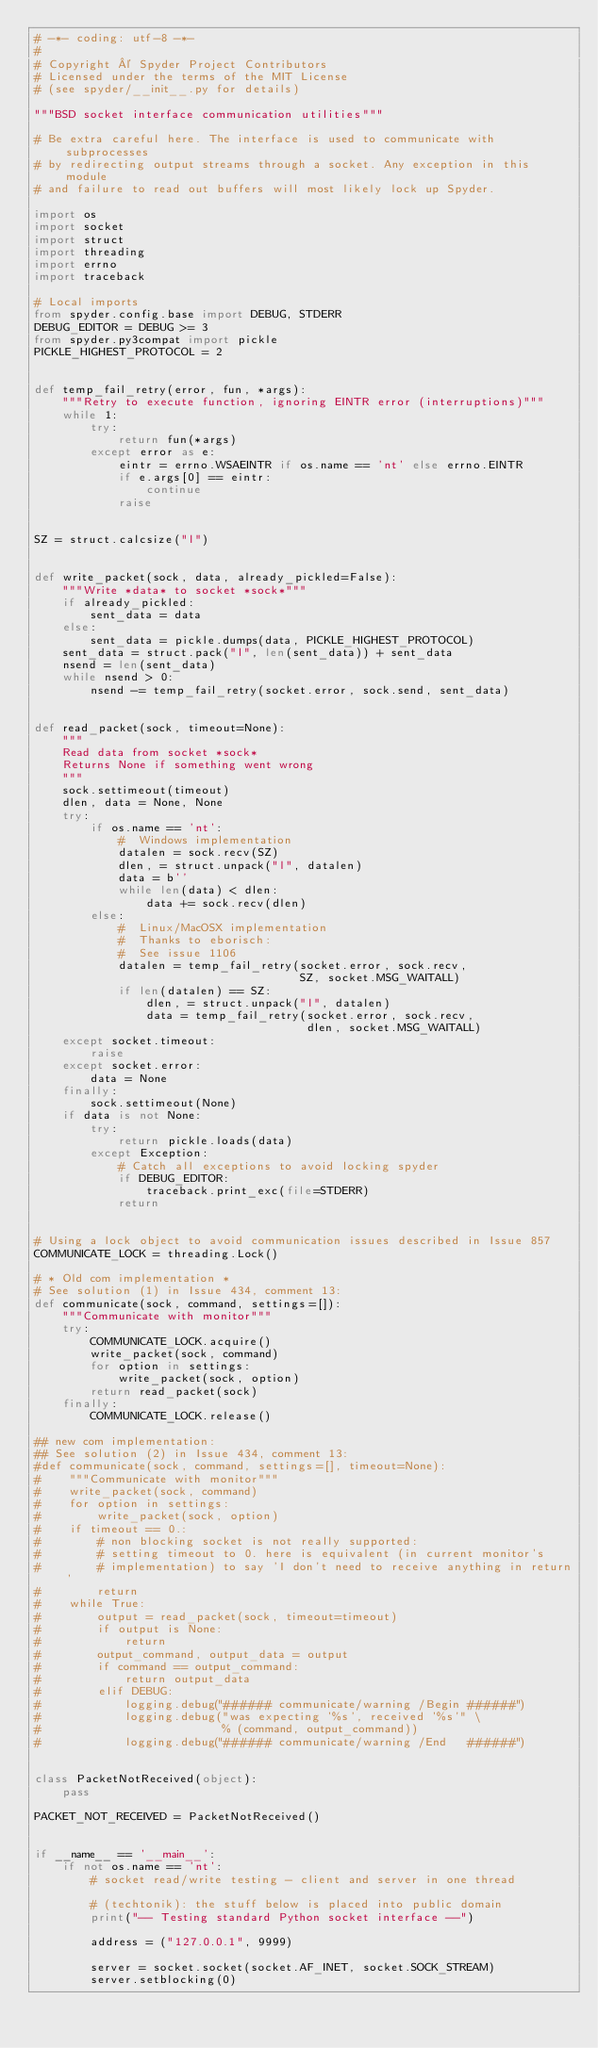<code> <loc_0><loc_0><loc_500><loc_500><_Python_># -*- coding: utf-8 -*-
#
# Copyright © Spyder Project Contributors
# Licensed under the terms of the MIT License
# (see spyder/__init__.py for details)

"""BSD socket interface communication utilities"""

# Be extra careful here. The interface is used to communicate with subprocesses
# by redirecting output streams through a socket. Any exception in this module
# and failure to read out buffers will most likely lock up Spyder.

import os
import socket
import struct
import threading
import errno
import traceback

# Local imports
from spyder.config.base import DEBUG, STDERR
DEBUG_EDITOR = DEBUG >= 3
from spyder.py3compat import pickle
PICKLE_HIGHEST_PROTOCOL = 2


def temp_fail_retry(error, fun, *args):
    """Retry to execute function, ignoring EINTR error (interruptions)"""
    while 1:
        try:
            return fun(*args)
        except error as e:
            eintr = errno.WSAEINTR if os.name == 'nt' else errno.EINTR
            if e.args[0] == eintr:
                continue
            raise


SZ = struct.calcsize("l")


def write_packet(sock, data, already_pickled=False):
    """Write *data* to socket *sock*"""
    if already_pickled:
        sent_data = data
    else:
        sent_data = pickle.dumps(data, PICKLE_HIGHEST_PROTOCOL)
    sent_data = struct.pack("l", len(sent_data)) + sent_data
    nsend = len(sent_data)
    while nsend > 0:
        nsend -= temp_fail_retry(socket.error, sock.send, sent_data)


def read_packet(sock, timeout=None):
    """
    Read data from socket *sock*
    Returns None if something went wrong
    """
    sock.settimeout(timeout)
    dlen, data = None, None
    try:
        if os.name == 'nt':
            #  Windows implementation
            datalen = sock.recv(SZ)
            dlen, = struct.unpack("l", datalen)
            data = b''
            while len(data) < dlen:
                data += sock.recv(dlen)
        else:
            #  Linux/MacOSX implementation
            #  Thanks to eborisch:
            #  See issue 1106
            datalen = temp_fail_retry(socket.error, sock.recv,
                                      SZ, socket.MSG_WAITALL)
            if len(datalen) == SZ:
                dlen, = struct.unpack("l", datalen)
                data = temp_fail_retry(socket.error, sock.recv,
                                       dlen, socket.MSG_WAITALL)
    except socket.timeout:
        raise
    except socket.error:
        data = None
    finally:
        sock.settimeout(None)
    if data is not None:
        try:
            return pickle.loads(data)
        except Exception:
            # Catch all exceptions to avoid locking spyder
            if DEBUG_EDITOR:
                traceback.print_exc(file=STDERR)
            return


# Using a lock object to avoid communication issues described in Issue 857
COMMUNICATE_LOCK = threading.Lock()

# * Old com implementation *
# See solution (1) in Issue 434, comment 13:
def communicate(sock, command, settings=[]):
    """Communicate with monitor"""
    try:
        COMMUNICATE_LOCK.acquire()
        write_packet(sock, command)
        for option in settings:
            write_packet(sock, option)
        return read_packet(sock)
    finally:
        COMMUNICATE_LOCK.release()

## new com implementation:
## See solution (2) in Issue 434, comment 13:
#def communicate(sock, command, settings=[], timeout=None):
#    """Communicate with monitor"""
#    write_packet(sock, command)
#    for option in settings:
#        write_packet(sock, option)
#    if timeout == 0.:
#        # non blocking socket is not really supported:
#        # setting timeout to 0. here is equivalent (in current monitor's 
#        # implementation) to say 'I don't need to receive anything in return'
#        return
#    while True:
#        output = read_packet(sock, timeout=timeout)
#        if output is None:
#            return
#        output_command, output_data = output
#        if command == output_command:
#            return output_data
#        elif DEBUG:
#            logging.debug("###### communicate/warning /Begin ######")
#            logging.debug("was expecting '%s', received '%s'" \
#                          % (command, output_command))
#            logging.debug("###### communicate/warning /End   ######")


class PacketNotReceived(object):
    pass

PACKET_NOT_RECEIVED = PacketNotReceived()


if __name__ == '__main__':
    if not os.name == 'nt':
        # socket read/write testing - client and server in one thread
        
        # (techtonik): the stuff below is placed into public domain
        print("-- Testing standard Python socket interface --")
    
        address = ("127.0.0.1", 9999)
        
        server = socket.socket(socket.AF_INET, socket.SOCK_STREAM)
        server.setblocking(0)</code> 